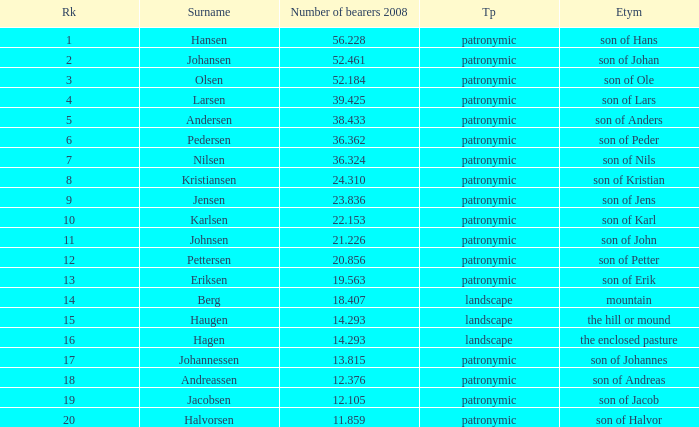What is Highest Number of Bearers 2008, when Surname is Jacobsen? 12.105. 